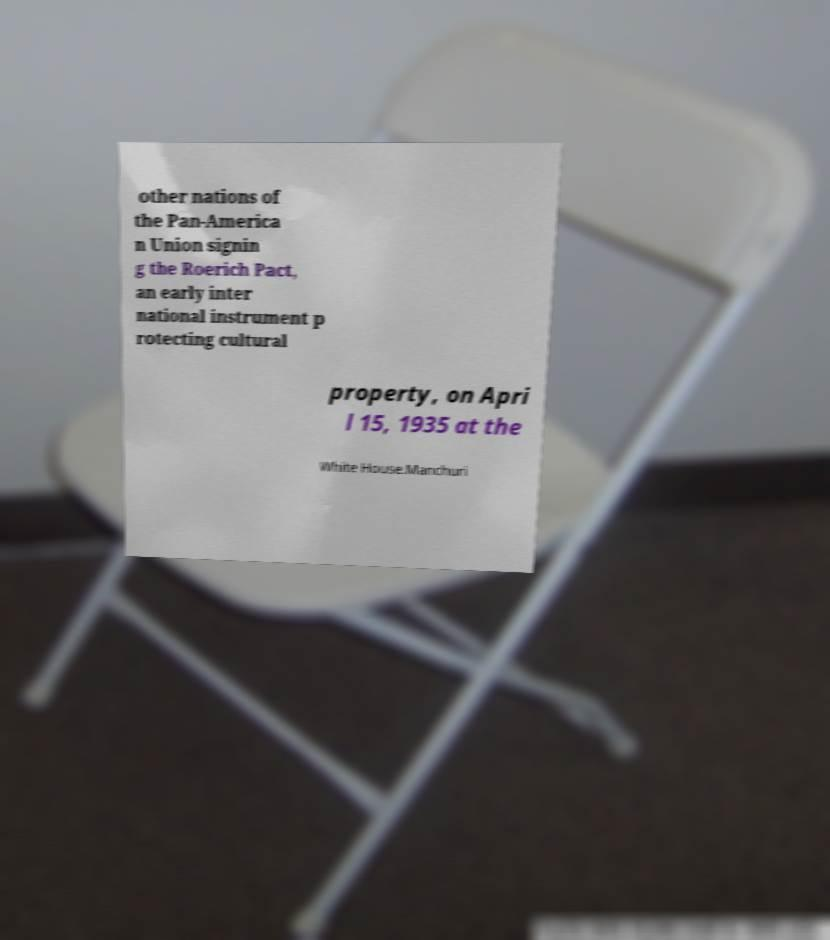There's text embedded in this image that I need extracted. Can you transcribe it verbatim? other nations of the Pan-America n Union signin g the Roerich Pact, an early inter national instrument p rotecting cultural property, on Apri l 15, 1935 at the White House.Manchuri 